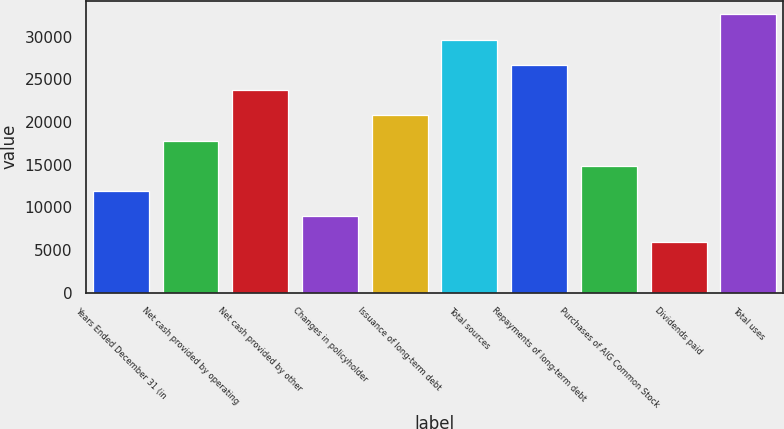<chart> <loc_0><loc_0><loc_500><loc_500><bar_chart><fcel>Years Ended December 31 (in<fcel>Net cash provided by operating<fcel>Net cash provided by other<fcel>Changes in policyholder<fcel>Issuance of long-term debt<fcel>Total sources<fcel>Repayments of long-term debt<fcel>Purchases of AIG Common Stock<fcel>Dividends paid<fcel>Total uses<nl><fcel>11900.8<fcel>17814.2<fcel>23727.6<fcel>8944.1<fcel>20770.9<fcel>29641<fcel>26684.3<fcel>14857.5<fcel>5987.4<fcel>32597.7<nl></chart> 